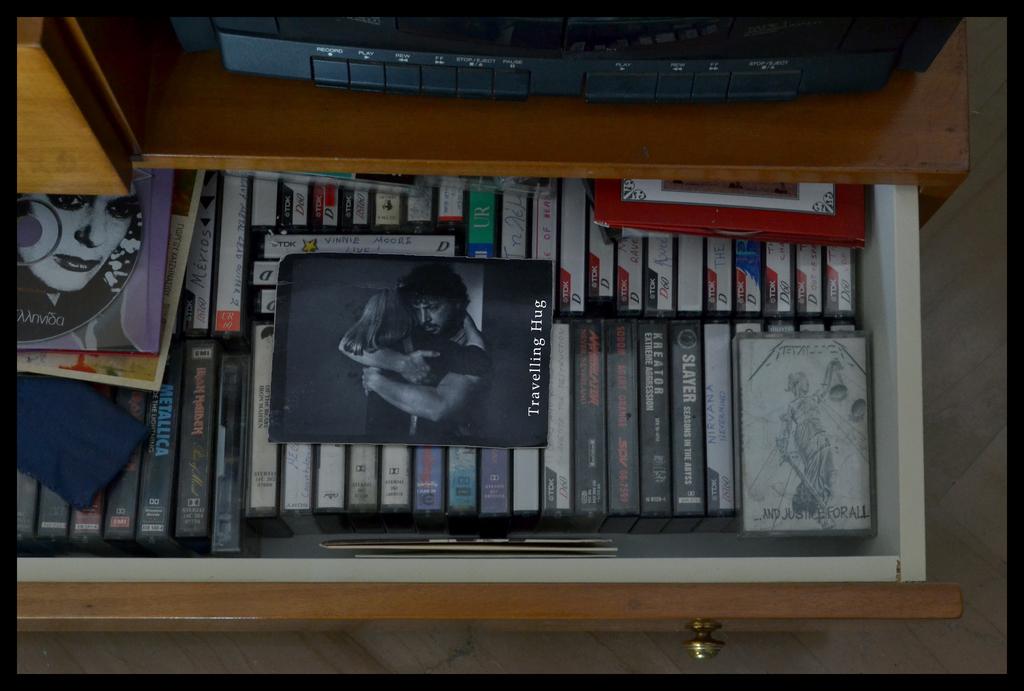What is the movie on top of the stack?
Offer a terse response. Travelling hug. What is the bottom right movie title?
Provide a short and direct response. And justice for all. 